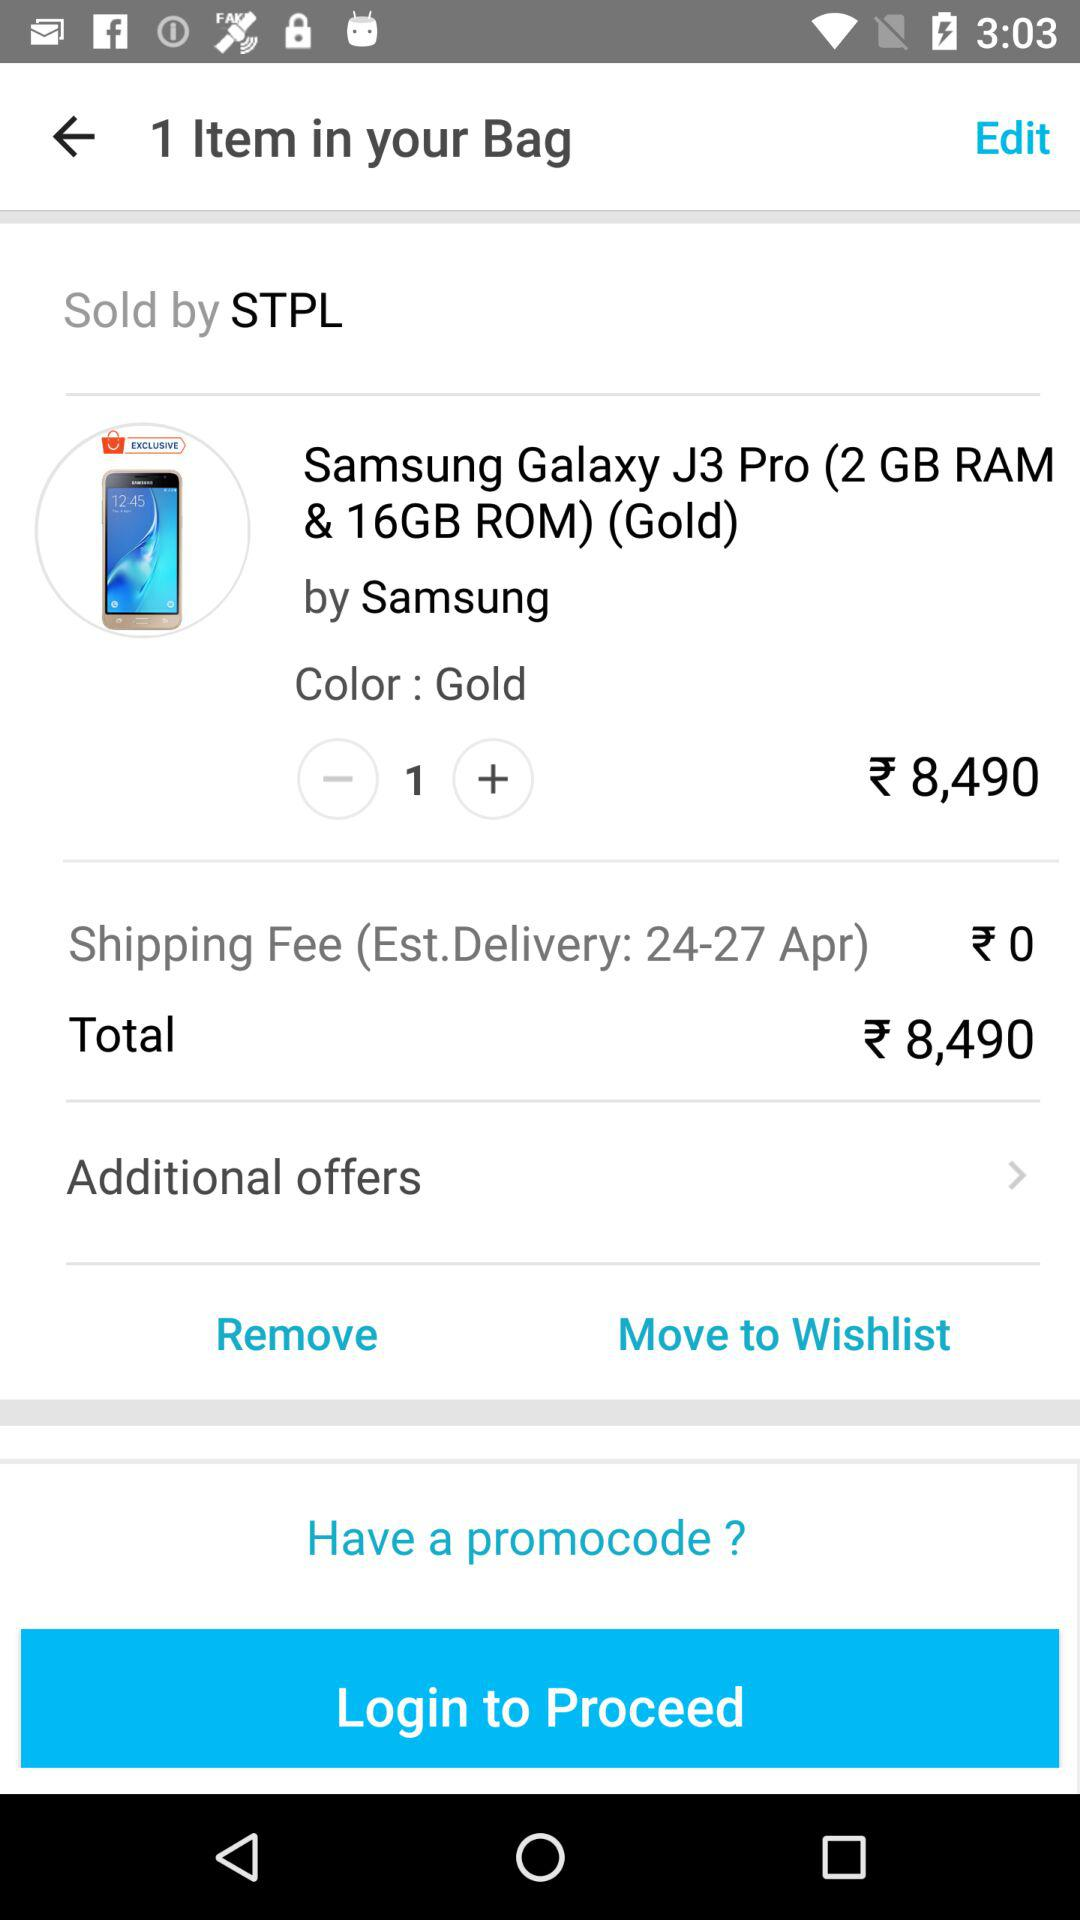How many items are in the cart?
Answer the question using a single word or phrase. 1 